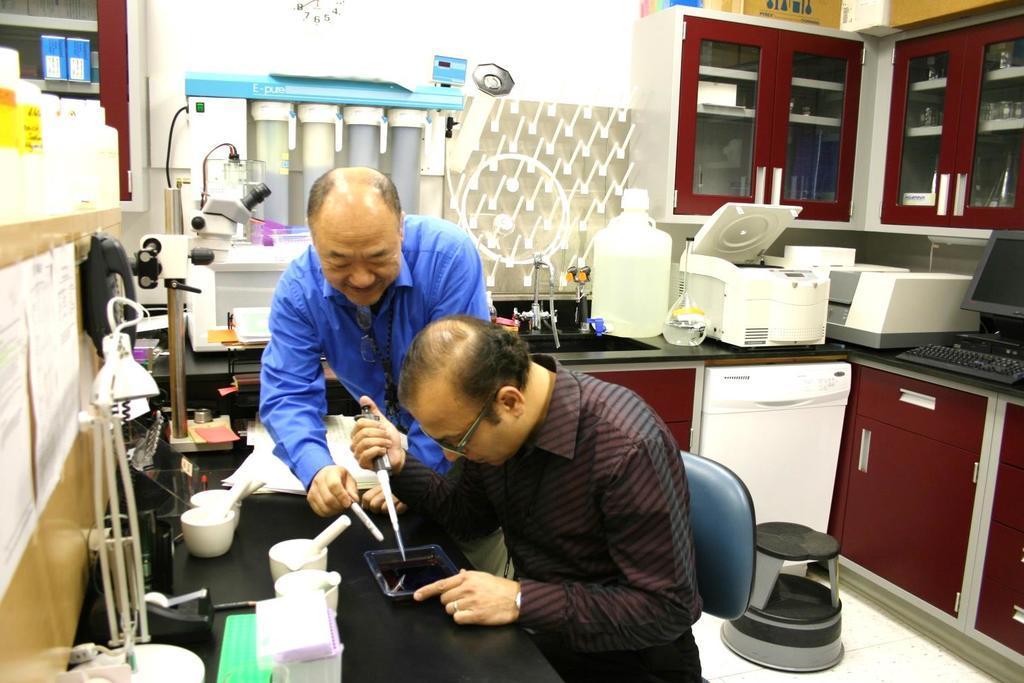Could you give a brief overview of what you see in this image? In this picture we can see cupboards and objects are inside the cupboard. we can see some equipment placed on the platform. On the right side we can see a monitor and a keyboard. On the floor we can see a stool. We can see men holding equipment in their hands and it seems they are doing some experiment. We can see few equipment and few other objects. On the left side we can see papers on the wall and there are bottles. At the top we can see a clock. 